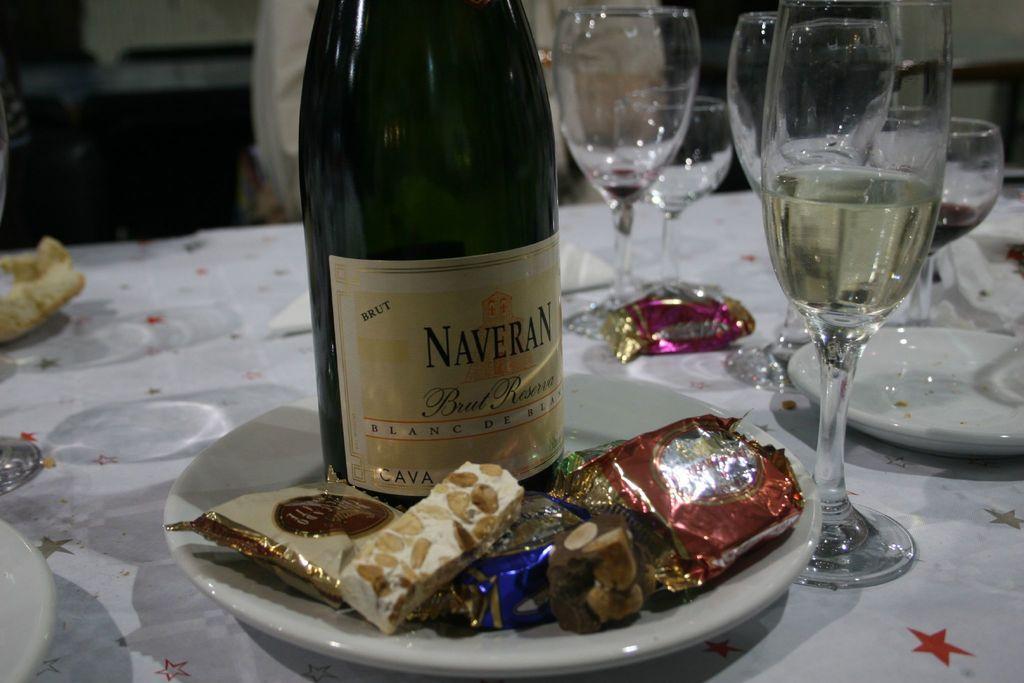How would you summarize this image in a sentence or two? In this image I can see a wine bottle,few chocolates and cookies on the white color plate. I can see few glasses,plates and few objects on the table. 